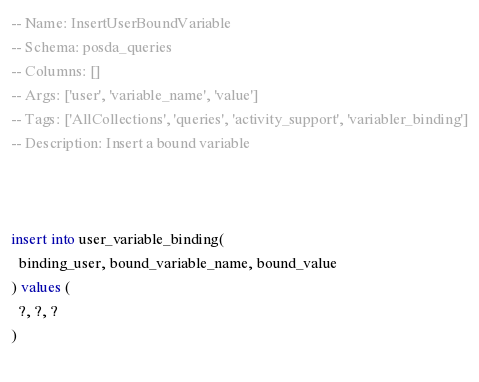Convert code to text. <code><loc_0><loc_0><loc_500><loc_500><_SQL_>-- Name: InsertUserBoundVariable
-- Schema: posda_queries
-- Columns: []
-- Args: ['user', 'variable_name', 'value']
-- Tags: ['AllCollections', 'queries', 'activity_support', 'variabler_binding']
-- Description: Insert a bound variable



insert into user_variable_binding(
  binding_user, bound_variable_name, bound_value
) values (
  ?, ?, ?
)
 </code> 